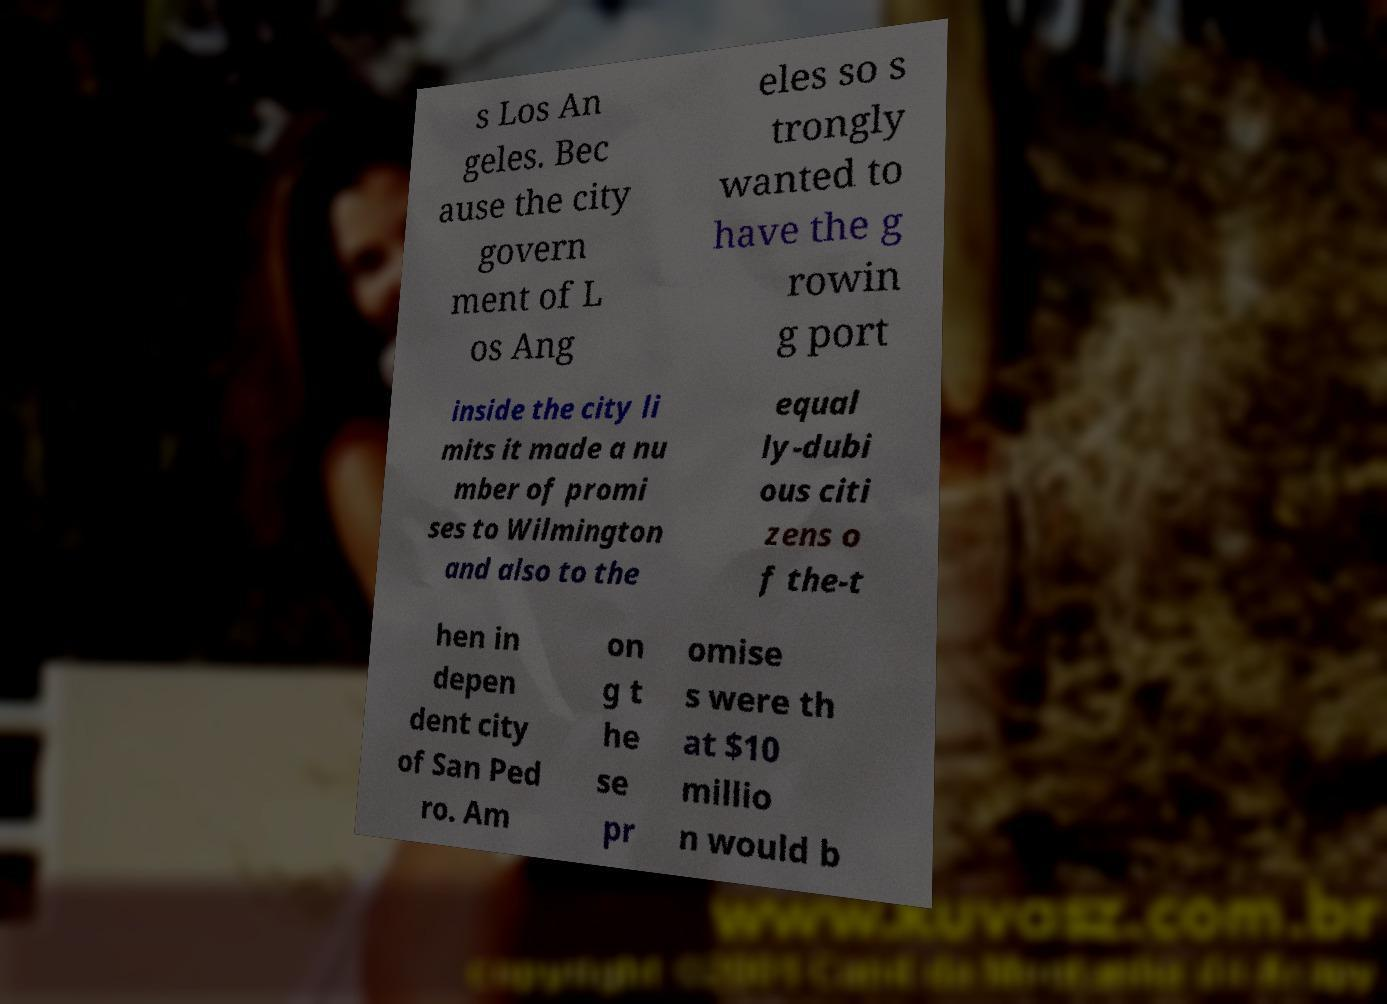Can you accurately transcribe the text from the provided image for me? s Los An geles. Bec ause the city govern ment of L os Ang eles so s trongly wanted to have the g rowin g port inside the city li mits it made a nu mber of promi ses to Wilmington and also to the equal ly-dubi ous citi zens o f the-t hen in depen dent city of San Ped ro. Am on g t he se pr omise s were th at $10 millio n would b 